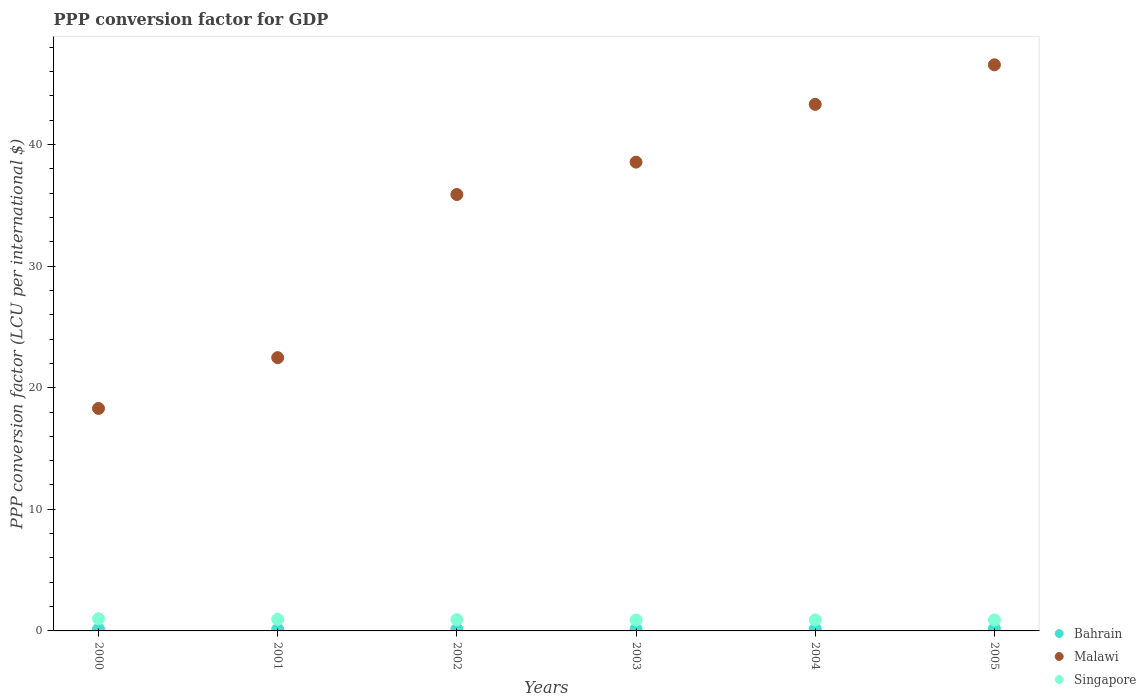How many different coloured dotlines are there?
Your answer should be compact. 3. What is the PPP conversion factor for GDP in Malawi in 2004?
Your answer should be very brief. 43.3. Across all years, what is the maximum PPP conversion factor for GDP in Bahrain?
Provide a short and direct response. 0.17. Across all years, what is the minimum PPP conversion factor for GDP in Malawi?
Provide a succinct answer. 18.29. In which year was the PPP conversion factor for GDP in Malawi minimum?
Your answer should be compact. 2000. What is the total PPP conversion factor for GDP in Malawi in the graph?
Your answer should be compact. 205.04. What is the difference between the PPP conversion factor for GDP in Bahrain in 2001 and that in 2005?
Make the answer very short. -0.04. What is the difference between the PPP conversion factor for GDP in Singapore in 2002 and the PPP conversion factor for GDP in Bahrain in 2005?
Give a very brief answer. 0.76. What is the average PPP conversion factor for GDP in Bahrain per year?
Ensure brevity in your answer.  0.15. In the year 2001, what is the difference between the PPP conversion factor for GDP in Bahrain and PPP conversion factor for GDP in Singapore?
Ensure brevity in your answer.  -0.82. In how many years, is the PPP conversion factor for GDP in Singapore greater than 2 LCU?
Your answer should be very brief. 0. What is the ratio of the PPP conversion factor for GDP in Malawi in 2001 to that in 2004?
Make the answer very short. 0.52. What is the difference between the highest and the second highest PPP conversion factor for GDP in Malawi?
Give a very brief answer. 3.25. What is the difference between the highest and the lowest PPP conversion factor for GDP in Singapore?
Your answer should be very brief. 0.1. In how many years, is the PPP conversion factor for GDP in Bahrain greater than the average PPP conversion factor for GDP in Bahrain taken over all years?
Provide a short and direct response. 2. Is the sum of the PPP conversion factor for GDP in Malawi in 2004 and 2005 greater than the maximum PPP conversion factor for GDP in Bahrain across all years?
Give a very brief answer. Yes. Does the PPP conversion factor for GDP in Singapore monotonically increase over the years?
Offer a terse response. No. Is the PPP conversion factor for GDP in Singapore strictly greater than the PPP conversion factor for GDP in Malawi over the years?
Your response must be concise. No. Is the PPP conversion factor for GDP in Malawi strictly less than the PPP conversion factor for GDP in Bahrain over the years?
Offer a terse response. No. How many dotlines are there?
Keep it short and to the point. 3. How many years are there in the graph?
Give a very brief answer. 6. Are the values on the major ticks of Y-axis written in scientific E-notation?
Your answer should be compact. No. How many legend labels are there?
Give a very brief answer. 3. What is the title of the graph?
Provide a succinct answer. PPP conversion factor for GDP. What is the label or title of the X-axis?
Give a very brief answer. Years. What is the label or title of the Y-axis?
Your answer should be compact. PPP conversion factor (LCU per international $). What is the PPP conversion factor (LCU per international $) of Bahrain in 2000?
Make the answer very short. 0.14. What is the PPP conversion factor (LCU per international $) of Malawi in 2000?
Your response must be concise. 18.29. What is the PPP conversion factor (LCU per international $) of Singapore in 2000?
Offer a terse response. 1. What is the PPP conversion factor (LCU per international $) in Bahrain in 2001?
Keep it short and to the point. 0.13. What is the PPP conversion factor (LCU per international $) in Malawi in 2001?
Your answer should be very brief. 22.47. What is the PPP conversion factor (LCU per international $) in Singapore in 2001?
Provide a short and direct response. 0.96. What is the PPP conversion factor (LCU per international $) in Bahrain in 2002?
Provide a short and direct response. 0.14. What is the PPP conversion factor (LCU per international $) of Malawi in 2002?
Ensure brevity in your answer.  35.89. What is the PPP conversion factor (LCU per international $) in Singapore in 2002?
Make the answer very short. 0.93. What is the PPP conversion factor (LCU per international $) in Bahrain in 2003?
Your answer should be very brief. 0.15. What is the PPP conversion factor (LCU per international $) of Malawi in 2003?
Offer a terse response. 38.55. What is the PPP conversion factor (LCU per international $) of Singapore in 2003?
Ensure brevity in your answer.  0.9. What is the PPP conversion factor (LCU per international $) in Bahrain in 2004?
Give a very brief answer. 0.16. What is the PPP conversion factor (LCU per international $) of Malawi in 2004?
Provide a succinct answer. 43.3. What is the PPP conversion factor (LCU per international $) of Singapore in 2004?
Provide a short and direct response. 0.91. What is the PPP conversion factor (LCU per international $) of Bahrain in 2005?
Provide a succinct answer. 0.17. What is the PPP conversion factor (LCU per international $) of Malawi in 2005?
Ensure brevity in your answer.  46.55. What is the PPP conversion factor (LCU per international $) of Singapore in 2005?
Ensure brevity in your answer.  0.9. Across all years, what is the maximum PPP conversion factor (LCU per international $) of Bahrain?
Offer a very short reply. 0.17. Across all years, what is the maximum PPP conversion factor (LCU per international $) in Malawi?
Ensure brevity in your answer.  46.55. Across all years, what is the maximum PPP conversion factor (LCU per international $) in Singapore?
Make the answer very short. 1. Across all years, what is the minimum PPP conversion factor (LCU per international $) in Bahrain?
Keep it short and to the point. 0.13. Across all years, what is the minimum PPP conversion factor (LCU per international $) in Malawi?
Give a very brief answer. 18.29. Across all years, what is the minimum PPP conversion factor (LCU per international $) in Singapore?
Your response must be concise. 0.9. What is the total PPP conversion factor (LCU per international $) of Bahrain in the graph?
Give a very brief answer. 0.89. What is the total PPP conversion factor (LCU per international $) in Malawi in the graph?
Give a very brief answer. 205.04. What is the total PPP conversion factor (LCU per international $) of Singapore in the graph?
Your answer should be compact. 5.6. What is the difference between the PPP conversion factor (LCU per international $) in Bahrain in 2000 and that in 2001?
Your answer should be very brief. 0.01. What is the difference between the PPP conversion factor (LCU per international $) of Malawi in 2000 and that in 2001?
Your answer should be very brief. -4.18. What is the difference between the PPP conversion factor (LCU per international $) of Singapore in 2000 and that in 2001?
Provide a short and direct response. 0.04. What is the difference between the PPP conversion factor (LCU per international $) in Bahrain in 2000 and that in 2002?
Give a very brief answer. 0.01. What is the difference between the PPP conversion factor (LCU per international $) in Malawi in 2000 and that in 2002?
Give a very brief answer. -17.59. What is the difference between the PPP conversion factor (LCU per international $) in Singapore in 2000 and that in 2002?
Provide a succinct answer. 0.07. What is the difference between the PPP conversion factor (LCU per international $) of Bahrain in 2000 and that in 2003?
Your answer should be very brief. -0. What is the difference between the PPP conversion factor (LCU per international $) in Malawi in 2000 and that in 2003?
Provide a succinct answer. -20.25. What is the difference between the PPP conversion factor (LCU per international $) in Singapore in 2000 and that in 2003?
Your answer should be very brief. 0.1. What is the difference between the PPP conversion factor (LCU per international $) of Bahrain in 2000 and that in 2004?
Your answer should be compact. -0.02. What is the difference between the PPP conversion factor (LCU per international $) of Malawi in 2000 and that in 2004?
Offer a very short reply. -25. What is the difference between the PPP conversion factor (LCU per international $) in Singapore in 2000 and that in 2004?
Your answer should be very brief. 0.09. What is the difference between the PPP conversion factor (LCU per international $) in Bahrain in 2000 and that in 2005?
Keep it short and to the point. -0.03. What is the difference between the PPP conversion factor (LCU per international $) of Malawi in 2000 and that in 2005?
Provide a short and direct response. -28.26. What is the difference between the PPP conversion factor (LCU per international $) of Bahrain in 2001 and that in 2002?
Provide a short and direct response. -0. What is the difference between the PPP conversion factor (LCU per international $) of Malawi in 2001 and that in 2002?
Your answer should be compact. -13.42. What is the difference between the PPP conversion factor (LCU per international $) of Singapore in 2001 and that in 2002?
Make the answer very short. 0.03. What is the difference between the PPP conversion factor (LCU per international $) in Bahrain in 2001 and that in 2003?
Your response must be concise. -0.01. What is the difference between the PPP conversion factor (LCU per international $) of Malawi in 2001 and that in 2003?
Your answer should be very brief. -16.08. What is the difference between the PPP conversion factor (LCU per international $) of Singapore in 2001 and that in 2003?
Keep it short and to the point. 0.06. What is the difference between the PPP conversion factor (LCU per international $) in Bahrain in 2001 and that in 2004?
Ensure brevity in your answer.  -0.02. What is the difference between the PPP conversion factor (LCU per international $) in Malawi in 2001 and that in 2004?
Provide a succinct answer. -20.83. What is the difference between the PPP conversion factor (LCU per international $) of Singapore in 2001 and that in 2004?
Ensure brevity in your answer.  0.05. What is the difference between the PPP conversion factor (LCU per international $) of Bahrain in 2001 and that in 2005?
Your answer should be very brief. -0.04. What is the difference between the PPP conversion factor (LCU per international $) of Malawi in 2001 and that in 2005?
Provide a succinct answer. -24.08. What is the difference between the PPP conversion factor (LCU per international $) in Singapore in 2001 and that in 2005?
Your response must be concise. 0.06. What is the difference between the PPP conversion factor (LCU per international $) of Bahrain in 2002 and that in 2003?
Offer a very short reply. -0.01. What is the difference between the PPP conversion factor (LCU per international $) in Malawi in 2002 and that in 2003?
Ensure brevity in your answer.  -2.66. What is the difference between the PPP conversion factor (LCU per international $) in Singapore in 2002 and that in 2003?
Your response must be concise. 0.03. What is the difference between the PPP conversion factor (LCU per international $) in Bahrain in 2002 and that in 2004?
Provide a succinct answer. -0.02. What is the difference between the PPP conversion factor (LCU per international $) of Malawi in 2002 and that in 2004?
Provide a succinct answer. -7.41. What is the difference between the PPP conversion factor (LCU per international $) in Singapore in 2002 and that in 2004?
Offer a terse response. 0.02. What is the difference between the PPP conversion factor (LCU per international $) in Bahrain in 2002 and that in 2005?
Offer a terse response. -0.04. What is the difference between the PPP conversion factor (LCU per international $) of Malawi in 2002 and that in 2005?
Provide a succinct answer. -10.66. What is the difference between the PPP conversion factor (LCU per international $) in Singapore in 2002 and that in 2005?
Give a very brief answer. 0.03. What is the difference between the PPP conversion factor (LCU per international $) of Bahrain in 2003 and that in 2004?
Your answer should be compact. -0.01. What is the difference between the PPP conversion factor (LCU per international $) in Malawi in 2003 and that in 2004?
Offer a very short reply. -4.75. What is the difference between the PPP conversion factor (LCU per international $) in Singapore in 2003 and that in 2004?
Provide a succinct answer. -0.01. What is the difference between the PPP conversion factor (LCU per international $) of Bahrain in 2003 and that in 2005?
Offer a terse response. -0.03. What is the difference between the PPP conversion factor (LCU per international $) of Malawi in 2003 and that in 2005?
Your answer should be very brief. -8. What is the difference between the PPP conversion factor (LCU per international $) of Singapore in 2003 and that in 2005?
Your response must be concise. -0. What is the difference between the PPP conversion factor (LCU per international $) of Bahrain in 2004 and that in 2005?
Your answer should be compact. -0.02. What is the difference between the PPP conversion factor (LCU per international $) in Malawi in 2004 and that in 2005?
Make the answer very short. -3.25. What is the difference between the PPP conversion factor (LCU per international $) of Singapore in 2004 and that in 2005?
Offer a terse response. 0.01. What is the difference between the PPP conversion factor (LCU per international $) in Bahrain in 2000 and the PPP conversion factor (LCU per international $) in Malawi in 2001?
Give a very brief answer. -22.33. What is the difference between the PPP conversion factor (LCU per international $) in Bahrain in 2000 and the PPP conversion factor (LCU per international $) in Singapore in 2001?
Make the answer very short. -0.81. What is the difference between the PPP conversion factor (LCU per international $) of Malawi in 2000 and the PPP conversion factor (LCU per international $) of Singapore in 2001?
Your answer should be compact. 17.34. What is the difference between the PPP conversion factor (LCU per international $) of Bahrain in 2000 and the PPP conversion factor (LCU per international $) of Malawi in 2002?
Offer a very short reply. -35.74. What is the difference between the PPP conversion factor (LCU per international $) of Bahrain in 2000 and the PPP conversion factor (LCU per international $) of Singapore in 2002?
Offer a terse response. -0.79. What is the difference between the PPP conversion factor (LCU per international $) of Malawi in 2000 and the PPP conversion factor (LCU per international $) of Singapore in 2002?
Your response must be concise. 17.36. What is the difference between the PPP conversion factor (LCU per international $) in Bahrain in 2000 and the PPP conversion factor (LCU per international $) in Malawi in 2003?
Provide a short and direct response. -38.4. What is the difference between the PPP conversion factor (LCU per international $) of Bahrain in 2000 and the PPP conversion factor (LCU per international $) of Singapore in 2003?
Provide a short and direct response. -0.75. What is the difference between the PPP conversion factor (LCU per international $) in Malawi in 2000 and the PPP conversion factor (LCU per international $) in Singapore in 2003?
Provide a short and direct response. 17.4. What is the difference between the PPP conversion factor (LCU per international $) in Bahrain in 2000 and the PPP conversion factor (LCU per international $) in Malawi in 2004?
Offer a very short reply. -43.15. What is the difference between the PPP conversion factor (LCU per international $) of Bahrain in 2000 and the PPP conversion factor (LCU per international $) of Singapore in 2004?
Your answer should be compact. -0.77. What is the difference between the PPP conversion factor (LCU per international $) in Malawi in 2000 and the PPP conversion factor (LCU per international $) in Singapore in 2004?
Offer a very short reply. 17.38. What is the difference between the PPP conversion factor (LCU per international $) of Bahrain in 2000 and the PPP conversion factor (LCU per international $) of Malawi in 2005?
Make the answer very short. -46.41. What is the difference between the PPP conversion factor (LCU per international $) of Bahrain in 2000 and the PPP conversion factor (LCU per international $) of Singapore in 2005?
Keep it short and to the point. -0.76. What is the difference between the PPP conversion factor (LCU per international $) in Malawi in 2000 and the PPP conversion factor (LCU per international $) in Singapore in 2005?
Provide a succinct answer. 17.39. What is the difference between the PPP conversion factor (LCU per international $) in Bahrain in 2001 and the PPP conversion factor (LCU per international $) in Malawi in 2002?
Offer a very short reply. -35.75. What is the difference between the PPP conversion factor (LCU per international $) in Bahrain in 2001 and the PPP conversion factor (LCU per international $) in Singapore in 2002?
Ensure brevity in your answer.  -0.8. What is the difference between the PPP conversion factor (LCU per international $) in Malawi in 2001 and the PPP conversion factor (LCU per international $) in Singapore in 2002?
Keep it short and to the point. 21.54. What is the difference between the PPP conversion factor (LCU per international $) of Bahrain in 2001 and the PPP conversion factor (LCU per international $) of Malawi in 2003?
Keep it short and to the point. -38.41. What is the difference between the PPP conversion factor (LCU per international $) of Bahrain in 2001 and the PPP conversion factor (LCU per international $) of Singapore in 2003?
Keep it short and to the point. -0.76. What is the difference between the PPP conversion factor (LCU per international $) of Malawi in 2001 and the PPP conversion factor (LCU per international $) of Singapore in 2003?
Offer a very short reply. 21.57. What is the difference between the PPP conversion factor (LCU per international $) in Bahrain in 2001 and the PPP conversion factor (LCU per international $) in Malawi in 2004?
Your response must be concise. -43.16. What is the difference between the PPP conversion factor (LCU per international $) of Bahrain in 2001 and the PPP conversion factor (LCU per international $) of Singapore in 2004?
Keep it short and to the point. -0.78. What is the difference between the PPP conversion factor (LCU per international $) in Malawi in 2001 and the PPP conversion factor (LCU per international $) in Singapore in 2004?
Provide a short and direct response. 21.56. What is the difference between the PPP conversion factor (LCU per international $) of Bahrain in 2001 and the PPP conversion factor (LCU per international $) of Malawi in 2005?
Your answer should be compact. -46.41. What is the difference between the PPP conversion factor (LCU per international $) of Bahrain in 2001 and the PPP conversion factor (LCU per international $) of Singapore in 2005?
Keep it short and to the point. -0.77. What is the difference between the PPP conversion factor (LCU per international $) of Malawi in 2001 and the PPP conversion factor (LCU per international $) of Singapore in 2005?
Offer a terse response. 21.57. What is the difference between the PPP conversion factor (LCU per international $) in Bahrain in 2002 and the PPP conversion factor (LCU per international $) in Malawi in 2003?
Keep it short and to the point. -38.41. What is the difference between the PPP conversion factor (LCU per international $) in Bahrain in 2002 and the PPP conversion factor (LCU per international $) in Singapore in 2003?
Your response must be concise. -0.76. What is the difference between the PPP conversion factor (LCU per international $) in Malawi in 2002 and the PPP conversion factor (LCU per international $) in Singapore in 2003?
Your answer should be compact. 34.99. What is the difference between the PPP conversion factor (LCU per international $) in Bahrain in 2002 and the PPP conversion factor (LCU per international $) in Malawi in 2004?
Offer a terse response. -43.16. What is the difference between the PPP conversion factor (LCU per international $) in Bahrain in 2002 and the PPP conversion factor (LCU per international $) in Singapore in 2004?
Ensure brevity in your answer.  -0.77. What is the difference between the PPP conversion factor (LCU per international $) in Malawi in 2002 and the PPP conversion factor (LCU per international $) in Singapore in 2004?
Your response must be concise. 34.97. What is the difference between the PPP conversion factor (LCU per international $) in Bahrain in 2002 and the PPP conversion factor (LCU per international $) in Malawi in 2005?
Provide a short and direct response. -46.41. What is the difference between the PPP conversion factor (LCU per international $) of Bahrain in 2002 and the PPP conversion factor (LCU per international $) of Singapore in 2005?
Your answer should be compact. -0.76. What is the difference between the PPP conversion factor (LCU per international $) of Malawi in 2002 and the PPP conversion factor (LCU per international $) of Singapore in 2005?
Offer a terse response. 34.98. What is the difference between the PPP conversion factor (LCU per international $) in Bahrain in 2003 and the PPP conversion factor (LCU per international $) in Malawi in 2004?
Your answer should be very brief. -43.15. What is the difference between the PPP conversion factor (LCU per international $) of Bahrain in 2003 and the PPP conversion factor (LCU per international $) of Singapore in 2004?
Make the answer very short. -0.76. What is the difference between the PPP conversion factor (LCU per international $) in Malawi in 2003 and the PPP conversion factor (LCU per international $) in Singapore in 2004?
Your answer should be compact. 37.64. What is the difference between the PPP conversion factor (LCU per international $) in Bahrain in 2003 and the PPP conversion factor (LCU per international $) in Malawi in 2005?
Offer a very short reply. -46.4. What is the difference between the PPP conversion factor (LCU per international $) in Bahrain in 2003 and the PPP conversion factor (LCU per international $) in Singapore in 2005?
Make the answer very short. -0.76. What is the difference between the PPP conversion factor (LCU per international $) in Malawi in 2003 and the PPP conversion factor (LCU per international $) in Singapore in 2005?
Offer a terse response. 37.65. What is the difference between the PPP conversion factor (LCU per international $) of Bahrain in 2004 and the PPP conversion factor (LCU per international $) of Malawi in 2005?
Make the answer very short. -46.39. What is the difference between the PPP conversion factor (LCU per international $) in Bahrain in 2004 and the PPP conversion factor (LCU per international $) in Singapore in 2005?
Offer a very short reply. -0.74. What is the difference between the PPP conversion factor (LCU per international $) in Malawi in 2004 and the PPP conversion factor (LCU per international $) in Singapore in 2005?
Give a very brief answer. 42.4. What is the average PPP conversion factor (LCU per international $) in Bahrain per year?
Give a very brief answer. 0.15. What is the average PPP conversion factor (LCU per international $) in Malawi per year?
Offer a terse response. 34.17. What is the average PPP conversion factor (LCU per international $) of Singapore per year?
Make the answer very short. 0.93. In the year 2000, what is the difference between the PPP conversion factor (LCU per international $) in Bahrain and PPP conversion factor (LCU per international $) in Malawi?
Ensure brevity in your answer.  -18.15. In the year 2000, what is the difference between the PPP conversion factor (LCU per international $) in Bahrain and PPP conversion factor (LCU per international $) in Singapore?
Your answer should be very brief. -0.86. In the year 2000, what is the difference between the PPP conversion factor (LCU per international $) in Malawi and PPP conversion factor (LCU per international $) in Singapore?
Ensure brevity in your answer.  17.29. In the year 2001, what is the difference between the PPP conversion factor (LCU per international $) in Bahrain and PPP conversion factor (LCU per international $) in Malawi?
Make the answer very short. -22.33. In the year 2001, what is the difference between the PPP conversion factor (LCU per international $) in Bahrain and PPP conversion factor (LCU per international $) in Singapore?
Provide a succinct answer. -0.82. In the year 2001, what is the difference between the PPP conversion factor (LCU per international $) in Malawi and PPP conversion factor (LCU per international $) in Singapore?
Provide a short and direct response. 21.51. In the year 2002, what is the difference between the PPP conversion factor (LCU per international $) in Bahrain and PPP conversion factor (LCU per international $) in Malawi?
Offer a terse response. -35.75. In the year 2002, what is the difference between the PPP conversion factor (LCU per international $) in Bahrain and PPP conversion factor (LCU per international $) in Singapore?
Your answer should be compact. -0.79. In the year 2002, what is the difference between the PPP conversion factor (LCU per international $) of Malawi and PPP conversion factor (LCU per international $) of Singapore?
Your answer should be very brief. 34.95. In the year 2003, what is the difference between the PPP conversion factor (LCU per international $) in Bahrain and PPP conversion factor (LCU per international $) in Malawi?
Keep it short and to the point. -38.4. In the year 2003, what is the difference between the PPP conversion factor (LCU per international $) in Bahrain and PPP conversion factor (LCU per international $) in Singapore?
Give a very brief answer. -0.75. In the year 2003, what is the difference between the PPP conversion factor (LCU per international $) in Malawi and PPP conversion factor (LCU per international $) in Singapore?
Your answer should be very brief. 37.65. In the year 2004, what is the difference between the PPP conversion factor (LCU per international $) in Bahrain and PPP conversion factor (LCU per international $) in Malawi?
Provide a succinct answer. -43.14. In the year 2004, what is the difference between the PPP conversion factor (LCU per international $) in Bahrain and PPP conversion factor (LCU per international $) in Singapore?
Keep it short and to the point. -0.75. In the year 2004, what is the difference between the PPP conversion factor (LCU per international $) of Malawi and PPP conversion factor (LCU per international $) of Singapore?
Make the answer very short. 42.39. In the year 2005, what is the difference between the PPP conversion factor (LCU per international $) in Bahrain and PPP conversion factor (LCU per international $) in Malawi?
Offer a terse response. -46.38. In the year 2005, what is the difference between the PPP conversion factor (LCU per international $) of Bahrain and PPP conversion factor (LCU per international $) of Singapore?
Provide a short and direct response. -0.73. In the year 2005, what is the difference between the PPP conversion factor (LCU per international $) of Malawi and PPP conversion factor (LCU per international $) of Singapore?
Your answer should be very brief. 45.65. What is the ratio of the PPP conversion factor (LCU per international $) in Bahrain in 2000 to that in 2001?
Provide a succinct answer. 1.06. What is the ratio of the PPP conversion factor (LCU per international $) in Malawi in 2000 to that in 2001?
Provide a short and direct response. 0.81. What is the ratio of the PPP conversion factor (LCU per international $) in Singapore in 2000 to that in 2001?
Provide a short and direct response. 1.05. What is the ratio of the PPP conversion factor (LCU per international $) in Bahrain in 2000 to that in 2002?
Your answer should be very brief. 1.04. What is the ratio of the PPP conversion factor (LCU per international $) of Malawi in 2000 to that in 2002?
Offer a very short reply. 0.51. What is the ratio of the PPP conversion factor (LCU per international $) of Singapore in 2000 to that in 2002?
Keep it short and to the point. 1.08. What is the ratio of the PPP conversion factor (LCU per international $) of Bahrain in 2000 to that in 2003?
Provide a succinct answer. 0.98. What is the ratio of the PPP conversion factor (LCU per international $) in Malawi in 2000 to that in 2003?
Ensure brevity in your answer.  0.47. What is the ratio of the PPP conversion factor (LCU per international $) in Singapore in 2000 to that in 2003?
Your response must be concise. 1.12. What is the ratio of the PPP conversion factor (LCU per international $) of Bahrain in 2000 to that in 2004?
Provide a succinct answer. 0.9. What is the ratio of the PPP conversion factor (LCU per international $) of Malawi in 2000 to that in 2004?
Provide a short and direct response. 0.42. What is the ratio of the PPP conversion factor (LCU per international $) in Singapore in 2000 to that in 2004?
Provide a short and direct response. 1.1. What is the ratio of the PPP conversion factor (LCU per international $) of Bahrain in 2000 to that in 2005?
Offer a terse response. 0.82. What is the ratio of the PPP conversion factor (LCU per international $) of Malawi in 2000 to that in 2005?
Keep it short and to the point. 0.39. What is the ratio of the PPP conversion factor (LCU per international $) in Singapore in 2000 to that in 2005?
Offer a very short reply. 1.11. What is the ratio of the PPP conversion factor (LCU per international $) in Bahrain in 2001 to that in 2002?
Your response must be concise. 0.98. What is the ratio of the PPP conversion factor (LCU per international $) of Malawi in 2001 to that in 2002?
Give a very brief answer. 0.63. What is the ratio of the PPP conversion factor (LCU per international $) in Singapore in 2001 to that in 2002?
Your answer should be compact. 1.03. What is the ratio of the PPP conversion factor (LCU per international $) in Bahrain in 2001 to that in 2003?
Offer a very short reply. 0.92. What is the ratio of the PPP conversion factor (LCU per international $) in Malawi in 2001 to that in 2003?
Offer a very short reply. 0.58. What is the ratio of the PPP conversion factor (LCU per international $) in Singapore in 2001 to that in 2003?
Ensure brevity in your answer.  1.07. What is the ratio of the PPP conversion factor (LCU per international $) of Bahrain in 2001 to that in 2004?
Make the answer very short. 0.85. What is the ratio of the PPP conversion factor (LCU per international $) in Malawi in 2001 to that in 2004?
Offer a terse response. 0.52. What is the ratio of the PPP conversion factor (LCU per international $) of Singapore in 2001 to that in 2004?
Offer a very short reply. 1.05. What is the ratio of the PPP conversion factor (LCU per international $) of Bahrain in 2001 to that in 2005?
Keep it short and to the point. 0.77. What is the ratio of the PPP conversion factor (LCU per international $) in Malawi in 2001 to that in 2005?
Give a very brief answer. 0.48. What is the ratio of the PPP conversion factor (LCU per international $) in Singapore in 2001 to that in 2005?
Offer a terse response. 1.06. What is the ratio of the PPP conversion factor (LCU per international $) in Bahrain in 2002 to that in 2003?
Offer a very short reply. 0.94. What is the ratio of the PPP conversion factor (LCU per international $) in Malawi in 2002 to that in 2003?
Keep it short and to the point. 0.93. What is the ratio of the PPP conversion factor (LCU per international $) in Singapore in 2002 to that in 2003?
Your answer should be very brief. 1.04. What is the ratio of the PPP conversion factor (LCU per international $) in Bahrain in 2002 to that in 2004?
Offer a very short reply. 0.87. What is the ratio of the PPP conversion factor (LCU per international $) of Malawi in 2002 to that in 2004?
Your response must be concise. 0.83. What is the ratio of the PPP conversion factor (LCU per international $) in Singapore in 2002 to that in 2004?
Offer a very short reply. 1.02. What is the ratio of the PPP conversion factor (LCU per international $) of Bahrain in 2002 to that in 2005?
Make the answer very short. 0.79. What is the ratio of the PPP conversion factor (LCU per international $) in Malawi in 2002 to that in 2005?
Offer a very short reply. 0.77. What is the ratio of the PPP conversion factor (LCU per international $) of Singapore in 2002 to that in 2005?
Offer a very short reply. 1.03. What is the ratio of the PPP conversion factor (LCU per international $) in Bahrain in 2003 to that in 2004?
Offer a very short reply. 0.93. What is the ratio of the PPP conversion factor (LCU per international $) in Malawi in 2003 to that in 2004?
Your response must be concise. 0.89. What is the ratio of the PPP conversion factor (LCU per international $) of Singapore in 2003 to that in 2004?
Give a very brief answer. 0.99. What is the ratio of the PPP conversion factor (LCU per international $) in Bahrain in 2003 to that in 2005?
Keep it short and to the point. 0.84. What is the ratio of the PPP conversion factor (LCU per international $) in Malawi in 2003 to that in 2005?
Make the answer very short. 0.83. What is the ratio of the PPP conversion factor (LCU per international $) in Singapore in 2003 to that in 2005?
Give a very brief answer. 1. What is the ratio of the PPP conversion factor (LCU per international $) in Bahrain in 2004 to that in 2005?
Offer a very short reply. 0.91. What is the ratio of the PPP conversion factor (LCU per international $) of Malawi in 2004 to that in 2005?
Make the answer very short. 0.93. What is the ratio of the PPP conversion factor (LCU per international $) of Singapore in 2004 to that in 2005?
Give a very brief answer. 1.01. What is the difference between the highest and the second highest PPP conversion factor (LCU per international $) in Bahrain?
Provide a succinct answer. 0.02. What is the difference between the highest and the second highest PPP conversion factor (LCU per international $) of Malawi?
Provide a short and direct response. 3.25. What is the difference between the highest and the second highest PPP conversion factor (LCU per international $) in Singapore?
Provide a short and direct response. 0.04. What is the difference between the highest and the lowest PPP conversion factor (LCU per international $) of Bahrain?
Your answer should be very brief. 0.04. What is the difference between the highest and the lowest PPP conversion factor (LCU per international $) in Malawi?
Give a very brief answer. 28.26. What is the difference between the highest and the lowest PPP conversion factor (LCU per international $) of Singapore?
Your answer should be very brief. 0.1. 